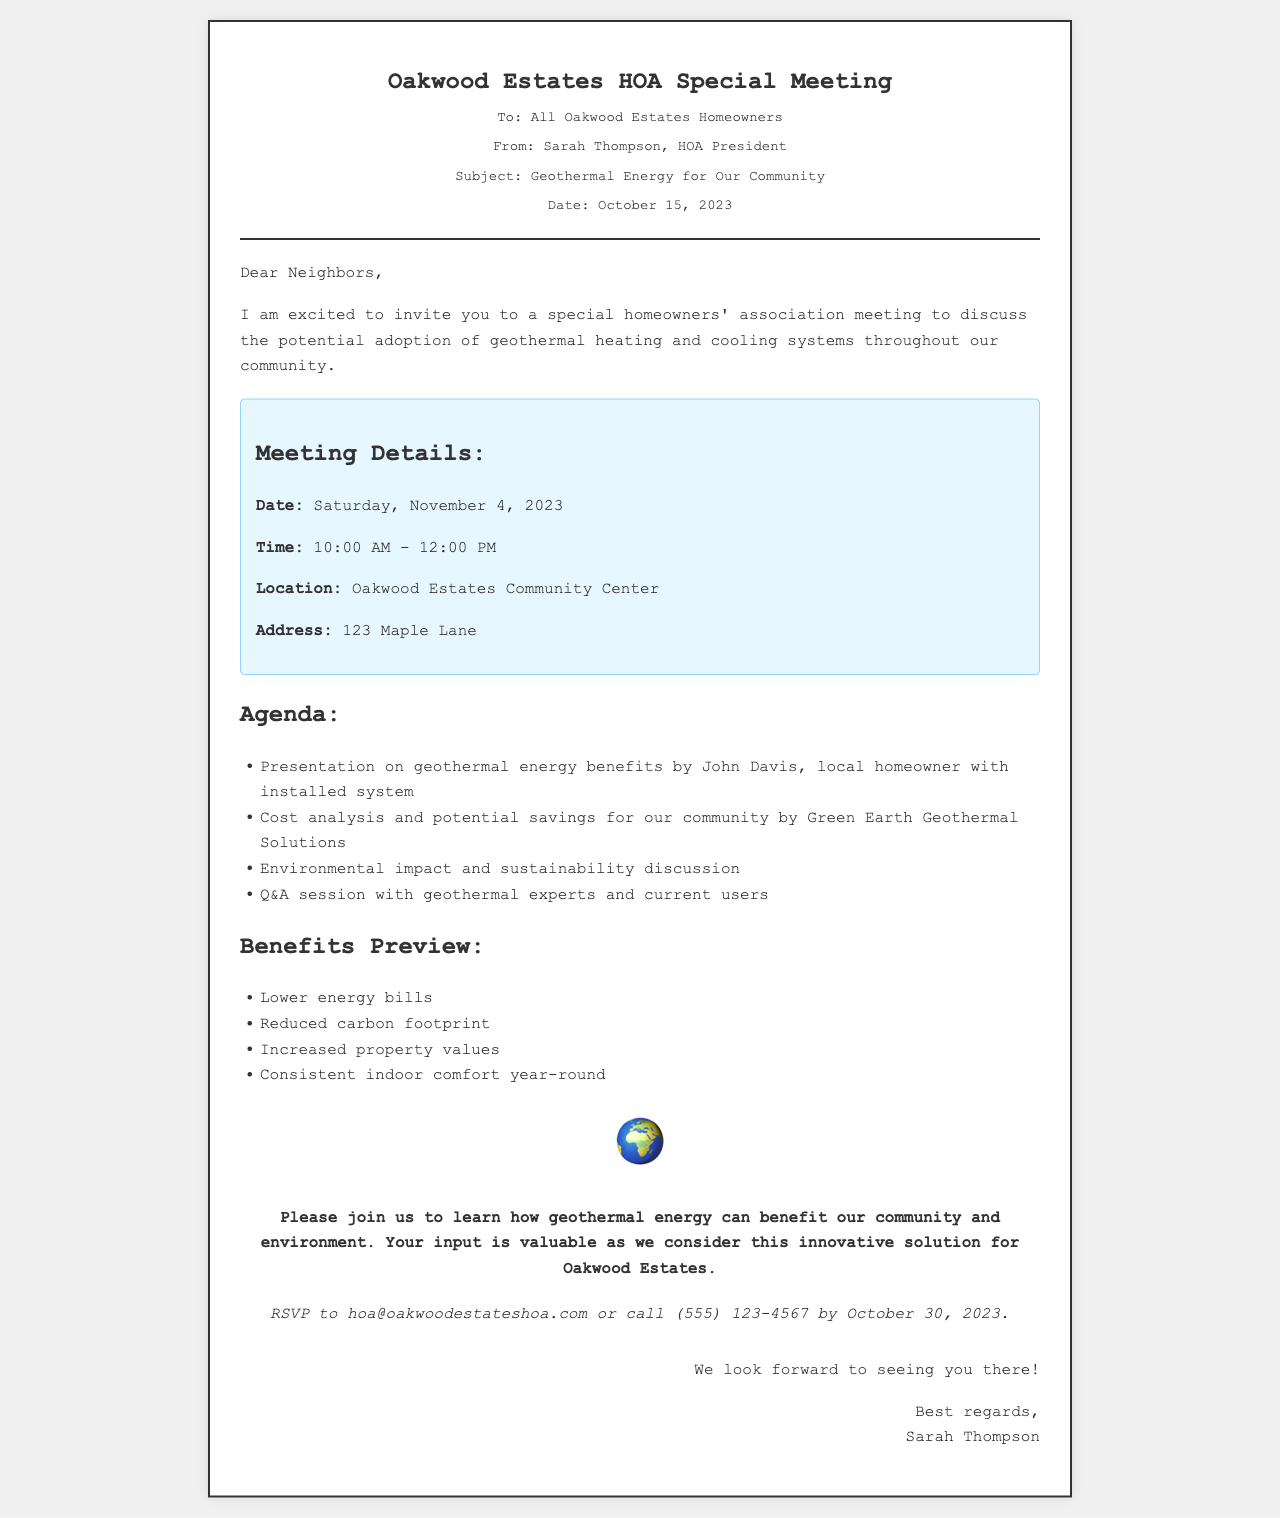What is the date of the meeting? The date of the meeting is clearly stated in the document as Saturday, November 4, 2023.
Answer: November 4, 2023 Who is the HOA President? The document mentions Sarah Thompson as the HOA President in the header information section.
Answer: Sarah Thompson What is the location of the meeting? The location for the meeting is provided as Oakwood Estates Community Center in the meeting details section.
Answer: Oakwood Estates Community Center What is one benefit of geothermal energy mentioned? The benefits preview section lists several advantages, one of which is lower energy bills.
Answer: Lower energy bills What will be discussed regarding environmental impact? The agenda specifies a discussion on environmental impact and sustainability, indicating that this aspect will be addressed.
Answer: Environmental impact and sustainability Who will present information on geothermal energy benefits? The agenda states that John Davis, a local homeowner with an installed system, will present information during the meeting.
Answer: John Davis By what date should homeowners RSVP? The RSVP section specifies that responses should be sent by October 30, 2023.
Answer: October 30, 2023 What is encouraged by the HOA President in the call-to-action? The call-to-action encourages homeowners to join the meeting and learn about geothermal energy benefits for the community.
Answer: Join us to learn What type of analysis will be presented by Green Earth Geothermal Solutions? The agenda indicates that a cost analysis and potential savings will be discussed by Green Earth Geothermal Solutions.
Answer: Cost analysis and potential savings 